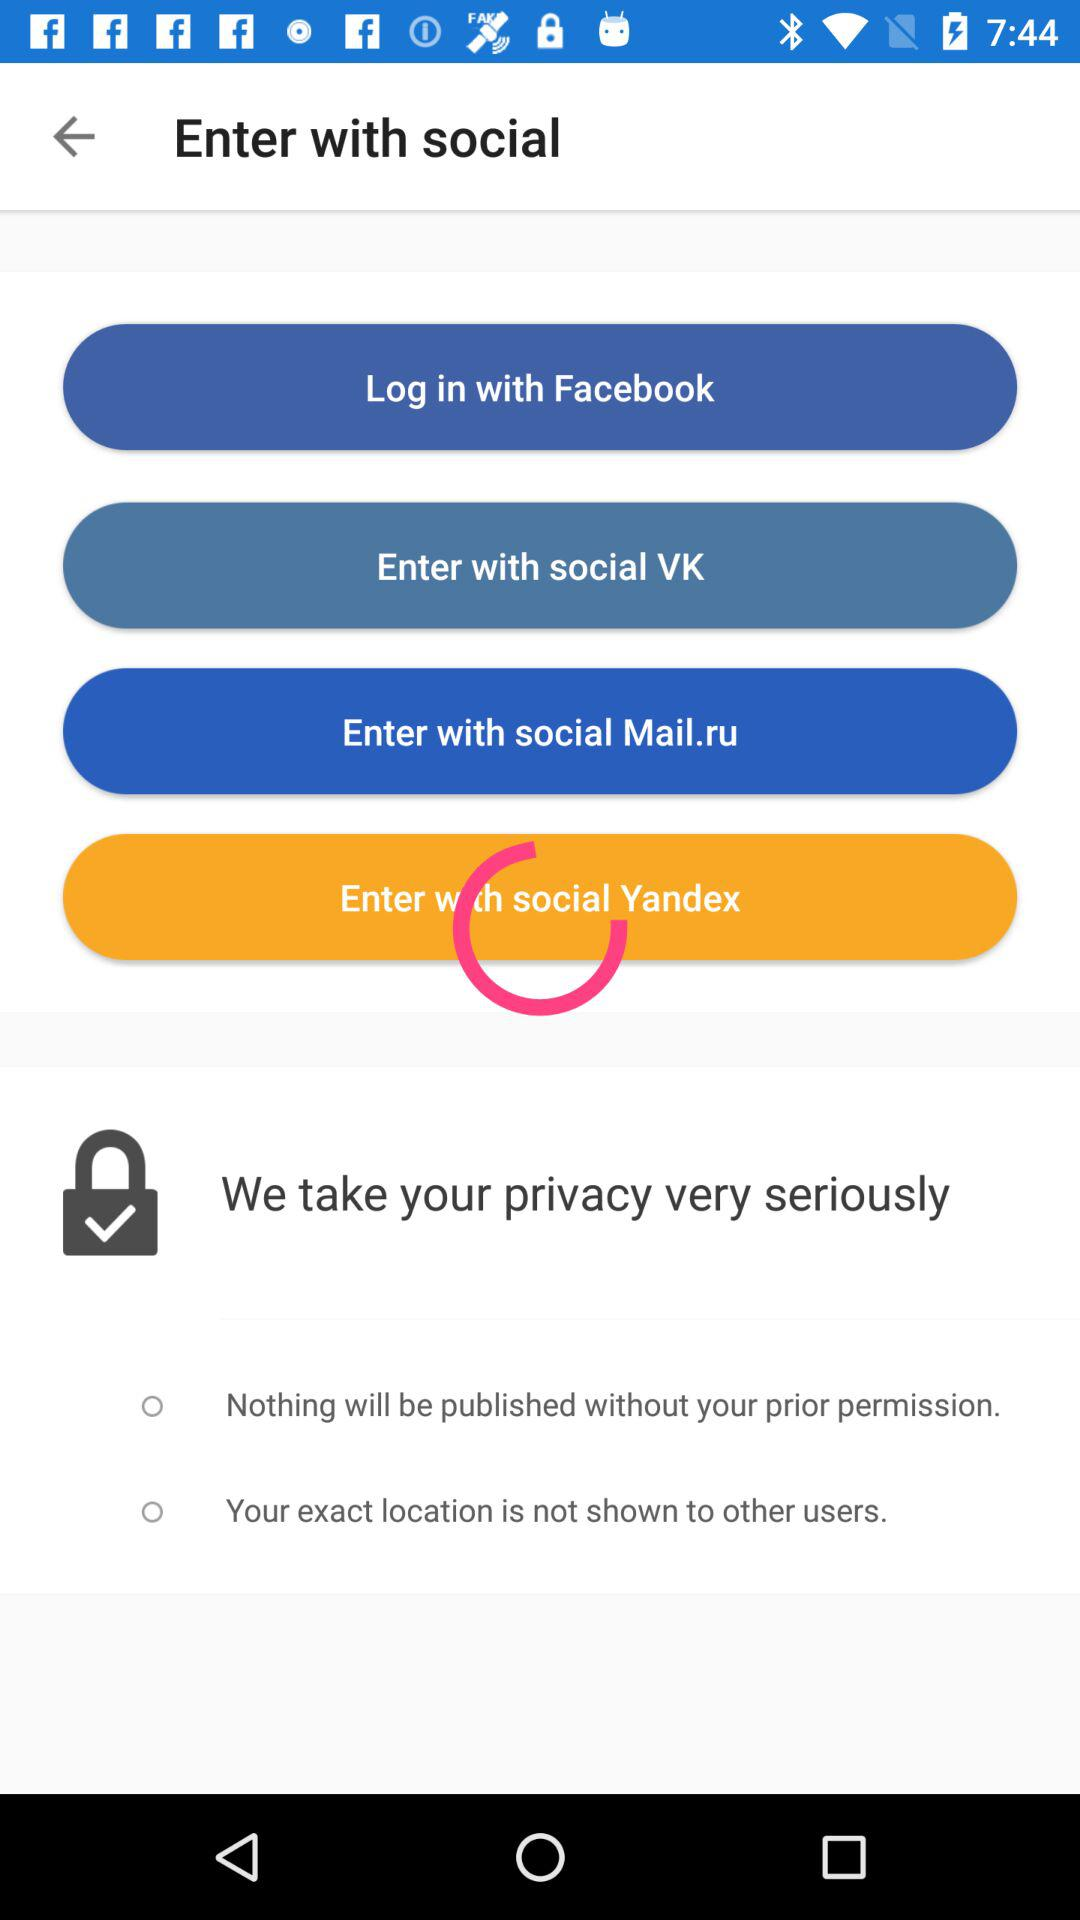Through what applications can we log in? You can log in with "Facebook", "social VK", "social mail.ru" and "social Yandex". 